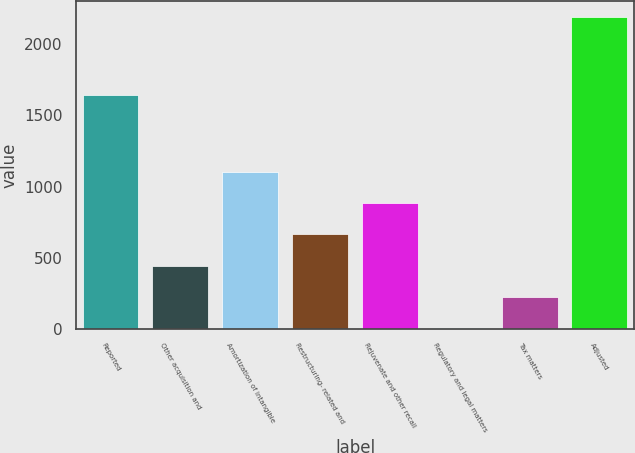<chart> <loc_0><loc_0><loc_500><loc_500><bar_chart><fcel>Reported<fcel>Other acquisition and<fcel>Amortization of intangible<fcel>Restructuring- related and<fcel>Rejuvenate and other recall<fcel>Regulatory and legal matters<fcel>Tax matters<fcel>Adjusted<nl><fcel>1647<fcel>444.4<fcel>1100.5<fcel>663.1<fcel>881.8<fcel>7<fcel>225.7<fcel>2194<nl></chart> 